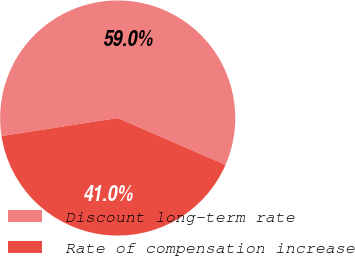<chart> <loc_0><loc_0><loc_500><loc_500><pie_chart><fcel>Discount long-term rate<fcel>Rate of compensation increase<nl><fcel>58.97%<fcel>41.03%<nl></chart> 